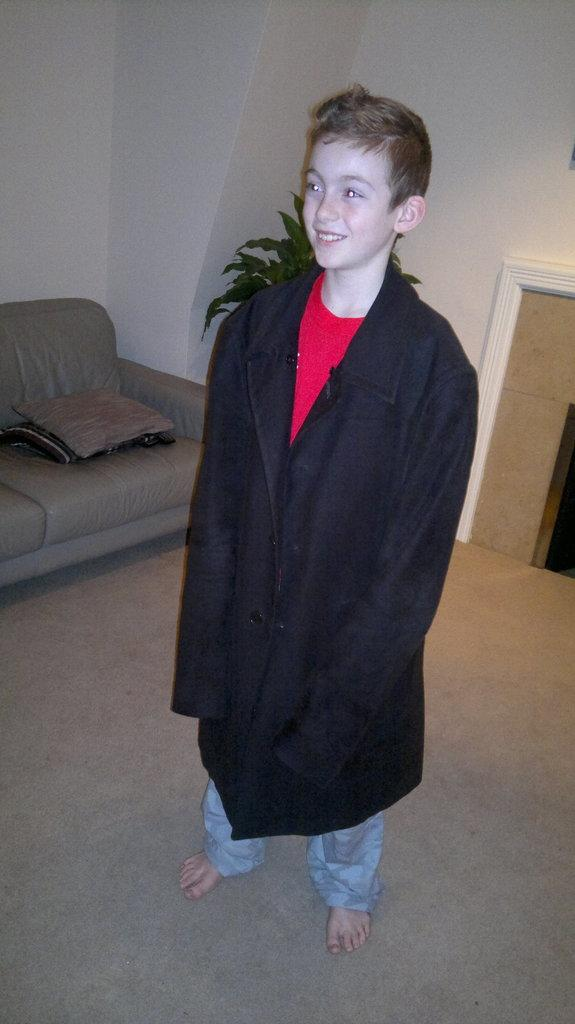What is the main subject of the image? There is a boy standing in the image. Can you describe the boy's clothing? The boy is wearing an oversized black coat. What piece of furniture can be seen on the left side of the image? There is a couch on the left side of the image. What type of vegetation is present in the image? There is a plant at the back of the image. What color are the walls in the image? The walls in the image are white. What type of record can be seen on the couch in the image? There is no record present in the image; it only features a boy, a couch, a plant, and white walls. 